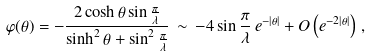<formula> <loc_0><loc_0><loc_500><loc_500>\varphi ( \theta ) = - \frac { 2 \cosh \theta \sin \frac { \pi } { \lambda } } { \sinh ^ { 2 } \theta + \sin ^ { 2 } \frac { \pi } { \lambda } } \, \sim \, - 4 \sin \frac { \pi } { \lambda } \, e ^ { - \left | \theta \right | } + O \left ( e ^ { - 2 \left | \theta \right | } \right ) \, ,</formula> 